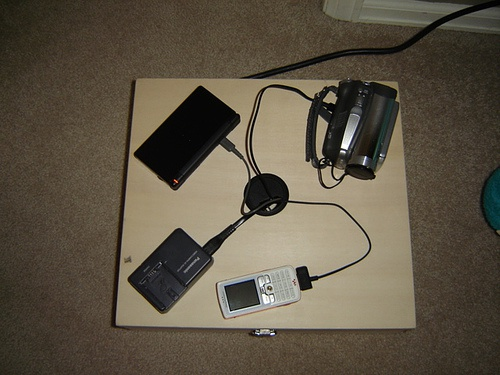Describe the objects in this image and their specific colors. I can see cell phone in black and olive tones and cell phone in black, darkgray, gray, and lightgray tones in this image. 